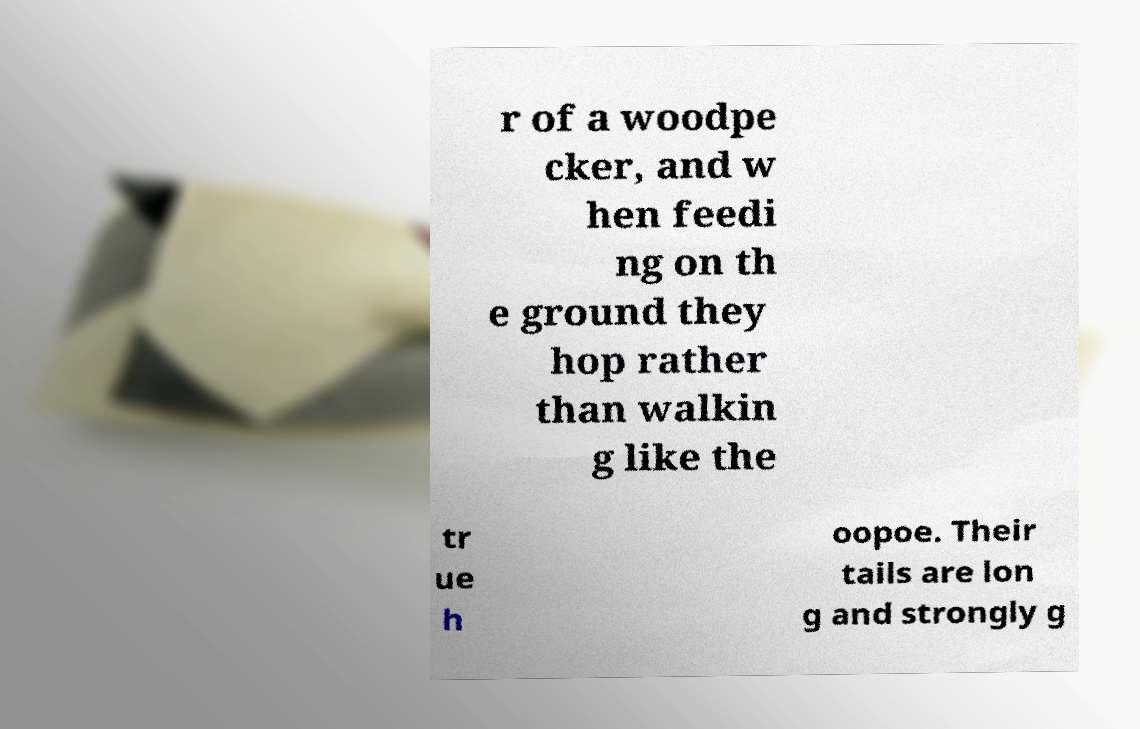Please identify and transcribe the text found in this image. r of a woodpe cker, and w hen feedi ng on th e ground they hop rather than walkin g like the tr ue h oopoe. Their tails are lon g and strongly g 